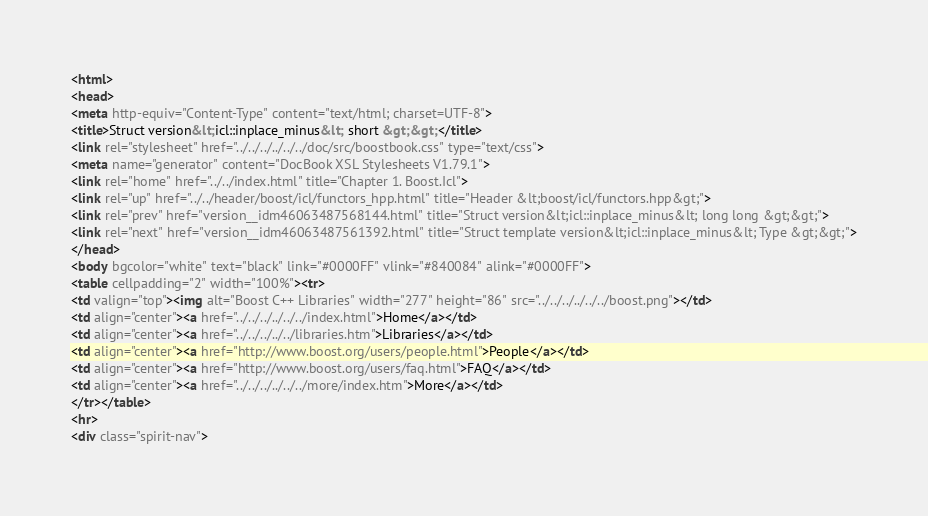Convert code to text. <code><loc_0><loc_0><loc_500><loc_500><_HTML_><html>
<head>
<meta http-equiv="Content-Type" content="text/html; charset=UTF-8">
<title>Struct version&lt;icl::inplace_minus&lt; short &gt;&gt;</title>
<link rel="stylesheet" href="../../../../../../doc/src/boostbook.css" type="text/css">
<meta name="generator" content="DocBook XSL Stylesheets V1.79.1">
<link rel="home" href="../../index.html" title="Chapter 1. Boost.Icl">
<link rel="up" href="../../header/boost/icl/functors_hpp.html" title="Header &lt;boost/icl/functors.hpp&gt;">
<link rel="prev" href="version__idm46063487568144.html" title="Struct version&lt;icl::inplace_minus&lt; long long &gt;&gt;">
<link rel="next" href="version__idm46063487561392.html" title="Struct template version&lt;icl::inplace_minus&lt; Type &gt;&gt;">
</head>
<body bgcolor="white" text="black" link="#0000FF" vlink="#840084" alink="#0000FF">
<table cellpadding="2" width="100%"><tr>
<td valign="top"><img alt="Boost C++ Libraries" width="277" height="86" src="../../../../../../boost.png"></td>
<td align="center"><a href="../../../../../../index.html">Home</a></td>
<td align="center"><a href="../../../../../libraries.htm">Libraries</a></td>
<td align="center"><a href="http://www.boost.org/users/people.html">People</a></td>
<td align="center"><a href="http://www.boost.org/users/faq.html">FAQ</a></td>
<td align="center"><a href="../../../../../../more/index.htm">More</a></td>
</tr></table>
<hr>
<div class="spirit-nav"></code> 